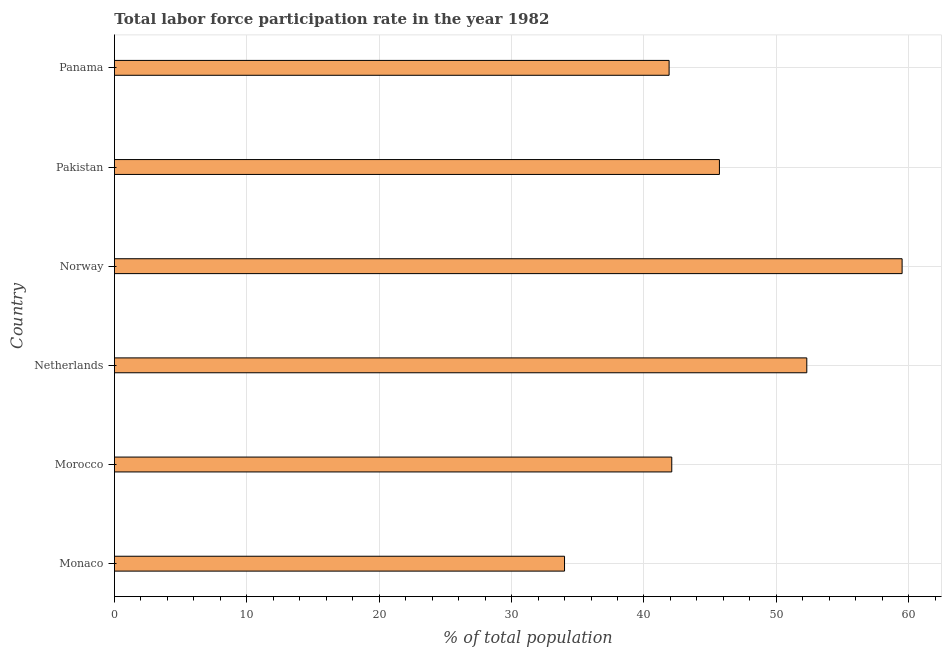Does the graph contain grids?
Give a very brief answer. Yes. What is the title of the graph?
Offer a very short reply. Total labor force participation rate in the year 1982. What is the label or title of the X-axis?
Your answer should be very brief. % of total population. What is the total labor force participation rate in Panama?
Make the answer very short. 41.9. Across all countries, what is the maximum total labor force participation rate?
Keep it short and to the point. 59.5. In which country was the total labor force participation rate minimum?
Ensure brevity in your answer.  Monaco. What is the sum of the total labor force participation rate?
Make the answer very short. 275.5. What is the difference between the total labor force participation rate in Netherlands and Panama?
Keep it short and to the point. 10.4. What is the average total labor force participation rate per country?
Offer a terse response. 45.92. What is the median total labor force participation rate?
Ensure brevity in your answer.  43.9. What is the ratio of the total labor force participation rate in Netherlands to that in Panama?
Your answer should be very brief. 1.25. Is the total labor force participation rate in Monaco less than that in Panama?
Your answer should be very brief. Yes. Is the sum of the total labor force participation rate in Morocco and Norway greater than the maximum total labor force participation rate across all countries?
Keep it short and to the point. Yes. In how many countries, is the total labor force participation rate greater than the average total labor force participation rate taken over all countries?
Keep it short and to the point. 2. Are all the bars in the graph horizontal?
Provide a succinct answer. Yes. How many countries are there in the graph?
Offer a very short reply. 6. What is the difference between two consecutive major ticks on the X-axis?
Ensure brevity in your answer.  10. What is the % of total population of Morocco?
Provide a short and direct response. 42.1. What is the % of total population in Netherlands?
Provide a succinct answer. 52.3. What is the % of total population of Norway?
Ensure brevity in your answer.  59.5. What is the % of total population in Pakistan?
Your answer should be very brief. 45.7. What is the % of total population in Panama?
Make the answer very short. 41.9. What is the difference between the % of total population in Monaco and Morocco?
Your response must be concise. -8.1. What is the difference between the % of total population in Monaco and Netherlands?
Your answer should be compact. -18.3. What is the difference between the % of total population in Monaco and Norway?
Make the answer very short. -25.5. What is the difference between the % of total population in Monaco and Panama?
Provide a succinct answer. -7.9. What is the difference between the % of total population in Morocco and Norway?
Your response must be concise. -17.4. What is the difference between the % of total population in Morocco and Pakistan?
Provide a succinct answer. -3.6. What is the difference between the % of total population in Morocco and Panama?
Ensure brevity in your answer.  0.2. What is the difference between the % of total population in Netherlands and Panama?
Provide a short and direct response. 10.4. What is the difference between the % of total population in Norway and Pakistan?
Make the answer very short. 13.8. What is the ratio of the % of total population in Monaco to that in Morocco?
Ensure brevity in your answer.  0.81. What is the ratio of the % of total population in Monaco to that in Netherlands?
Offer a very short reply. 0.65. What is the ratio of the % of total population in Monaco to that in Norway?
Your response must be concise. 0.57. What is the ratio of the % of total population in Monaco to that in Pakistan?
Your answer should be very brief. 0.74. What is the ratio of the % of total population in Monaco to that in Panama?
Ensure brevity in your answer.  0.81. What is the ratio of the % of total population in Morocco to that in Netherlands?
Keep it short and to the point. 0.81. What is the ratio of the % of total population in Morocco to that in Norway?
Provide a short and direct response. 0.71. What is the ratio of the % of total population in Morocco to that in Pakistan?
Offer a terse response. 0.92. What is the ratio of the % of total population in Morocco to that in Panama?
Your answer should be very brief. 1. What is the ratio of the % of total population in Netherlands to that in Norway?
Your response must be concise. 0.88. What is the ratio of the % of total population in Netherlands to that in Pakistan?
Provide a succinct answer. 1.14. What is the ratio of the % of total population in Netherlands to that in Panama?
Offer a very short reply. 1.25. What is the ratio of the % of total population in Norway to that in Pakistan?
Provide a succinct answer. 1.3. What is the ratio of the % of total population in Norway to that in Panama?
Your answer should be compact. 1.42. What is the ratio of the % of total population in Pakistan to that in Panama?
Make the answer very short. 1.09. 